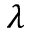Convert formula to latex. <formula><loc_0><loc_0><loc_500><loc_500>\lambda</formula> 